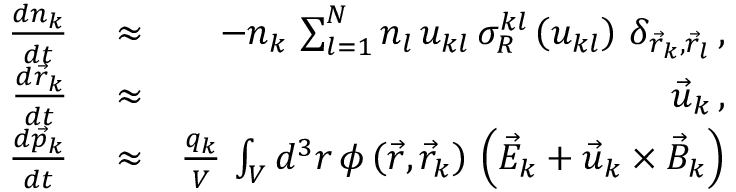Convert formula to latex. <formula><loc_0><loc_0><loc_500><loc_500>\begin{array} { r l r } { \frac { d n _ { k } } { d t } } & \approx } & { - n _ { k } \, \sum _ { l = 1 } ^ { N } n _ { l } \, u _ { k l } \, \sigma _ { R } ^ { k l } \left ( u _ { k l } \right ) \, \delta _ { \vec { r } _ { k } , \vec { r } _ { l } } \, , } \\ { \frac { d \vec { r } _ { k } } { d t } } & \approx } & { \vec { u } _ { k } \, , } \\ { \frac { d \vec { p } _ { k } } { d t } } & \approx } & { \frac { q _ { k } } { V } \, \int _ { V } d ^ { 3 } r \, \phi \left ( \vec { r } , \vec { r } _ { k } \right ) \, \left ( \vec { E } _ { k } + \vec { u } _ { k } \times \vec { B } _ { k } \right ) } \end{array}</formula> 